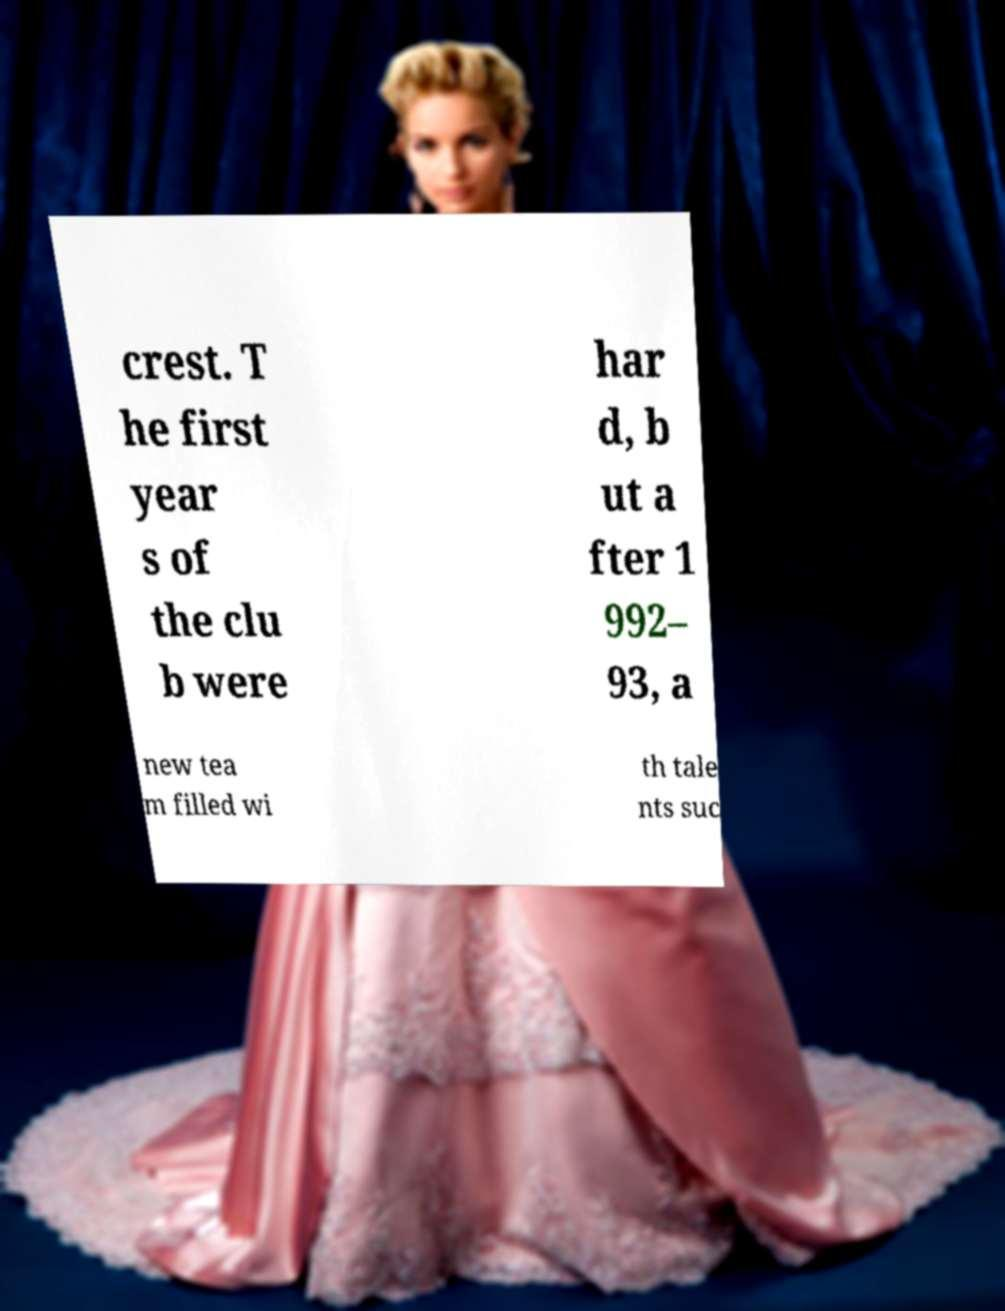Please read and relay the text visible in this image. What does it say? crest. T he first year s of the clu b were har d, b ut a fter 1 992– 93, a new tea m filled wi th tale nts suc 